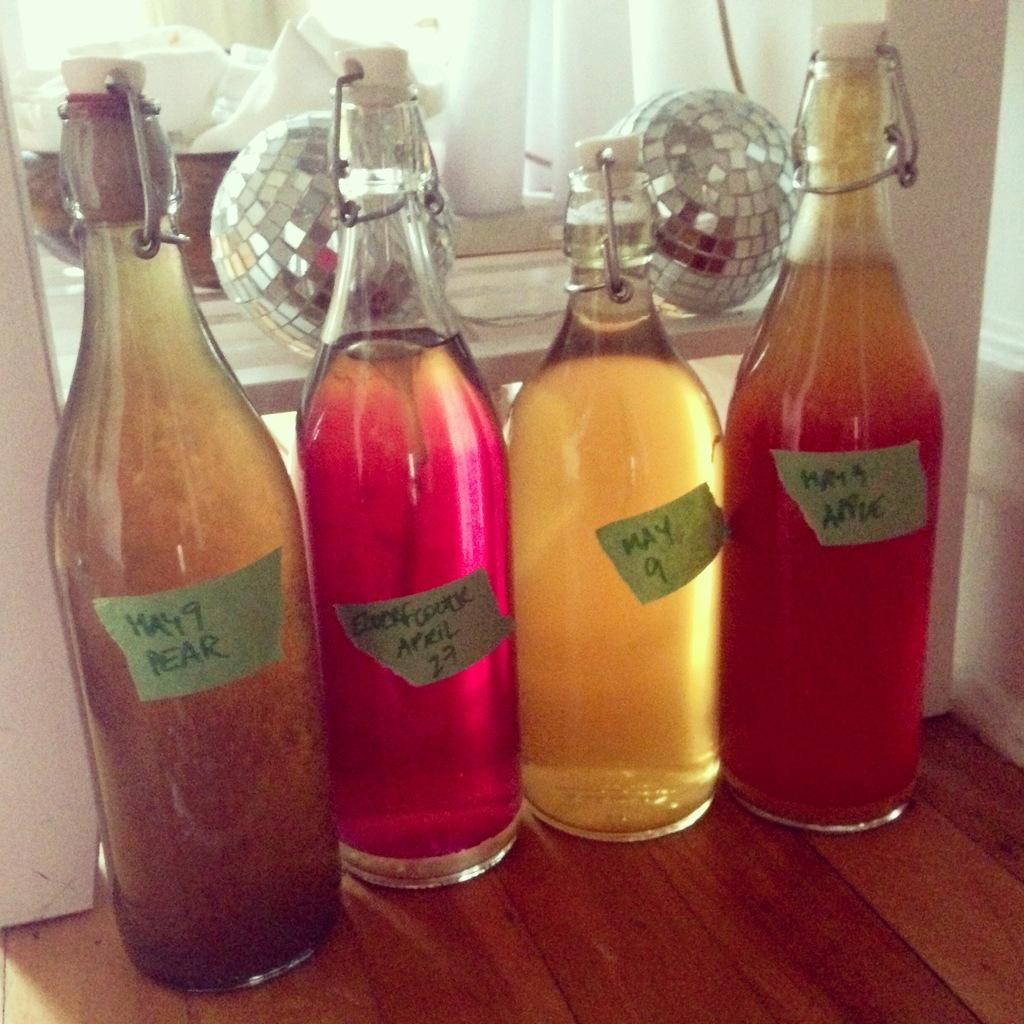<image>
Relay a brief, clear account of the picture shown. Four bottles of differently colored contents have a piece of paper with dates on it taped to them. 